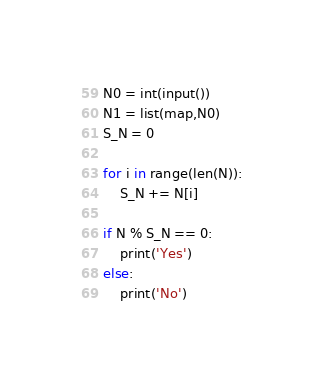<code> <loc_0><loc_0><loc_500><loc_500><_Python_>N0 = int(input())
N1 = list(map,N0)
S_N = 0

for i in range(len(N)):
    S_N += N[i]

if N % S_N == 0:
    print('Yes')
else:
    print('No')</code> 